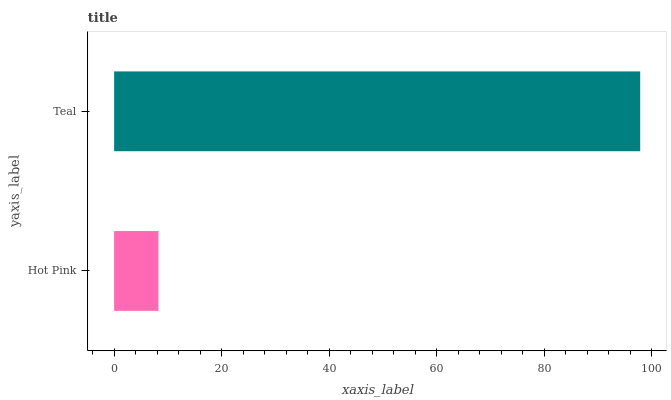Is Hot Pink the minimum?
Answer yes or no. Yes. Is Teal the maximum?
Answer yes or no. Yes. Is Teal the minimum?
Answer yes or no. No. Is Teal greater than Hot Pink?
Answer yes or no. Yes. Is Hot Pink less than Teal?
Answer yes or no. Yes. Is Hot Pink greater than Teal?
Answer yes or no. No. Is Teal less than Hot Pink?
Answer yes or no. No. Is Teal the high median?
Answer yes or no. Yes. Is Hot Pink the low median?
Answer yes or no. Yes. Is Hot Pink the high median?
Answer yes or no. No. Is Teal the low median?
Answer yes or no. No. 